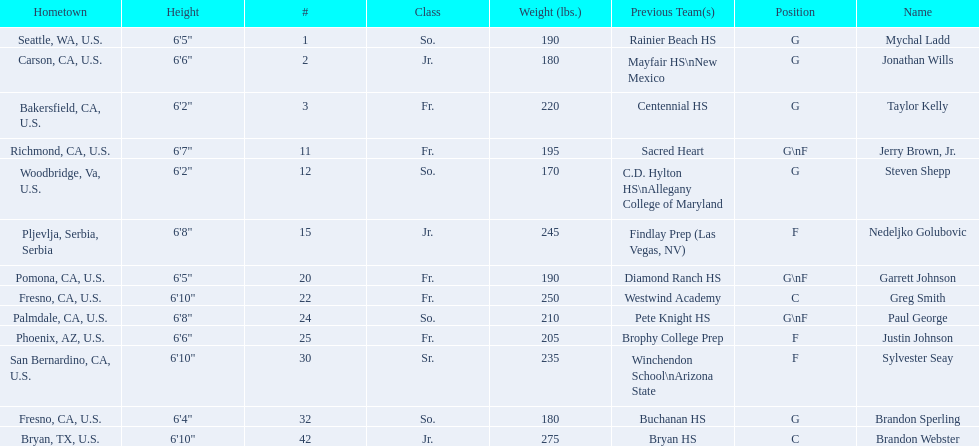What class was each team member in for the 2009-10 fresno state bulldogs? So., Jr., Fr., Fr., So., Jr., Fr., Fr., So., Fr., Sr., So., Jr. Which of these was outside of the us? Jr. Who was the player? Nedeljko Golubovic. 